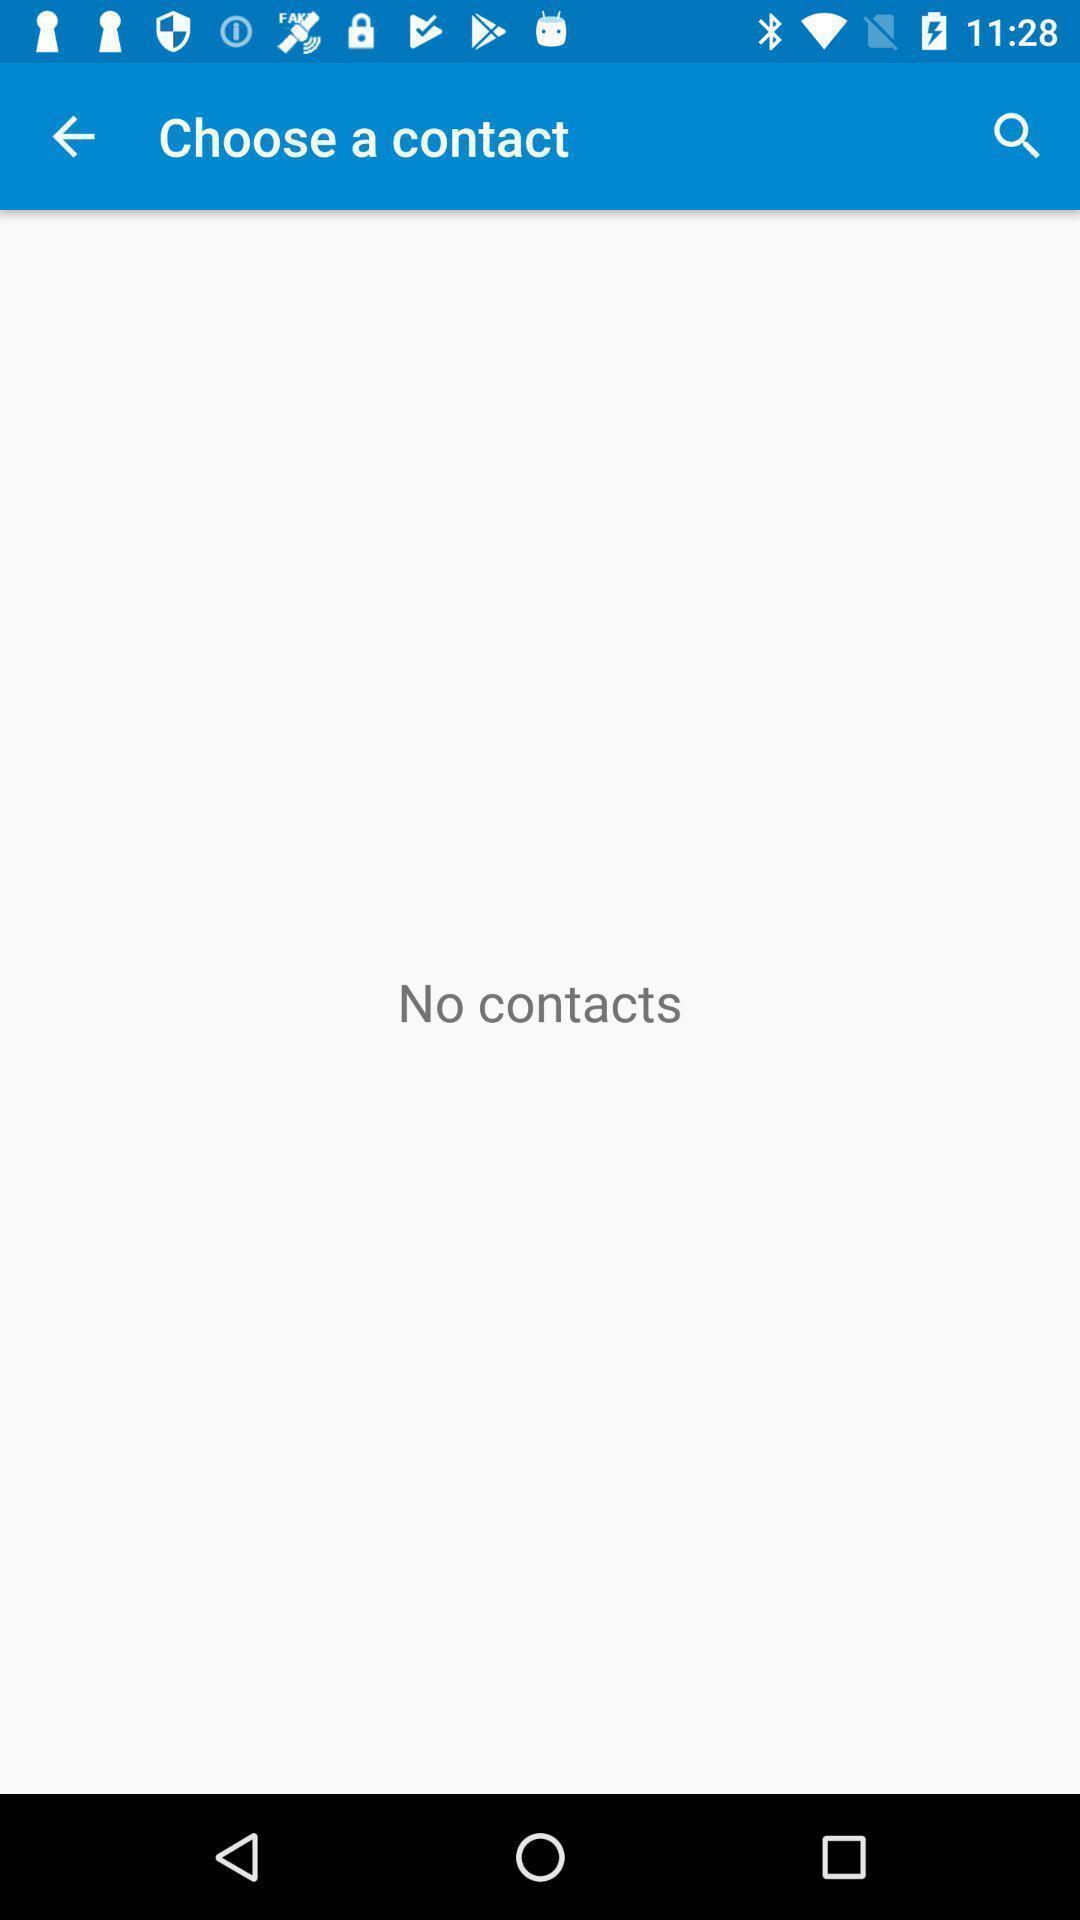Provide a detailed account of this screenshot. Page showing to choose a contact. 